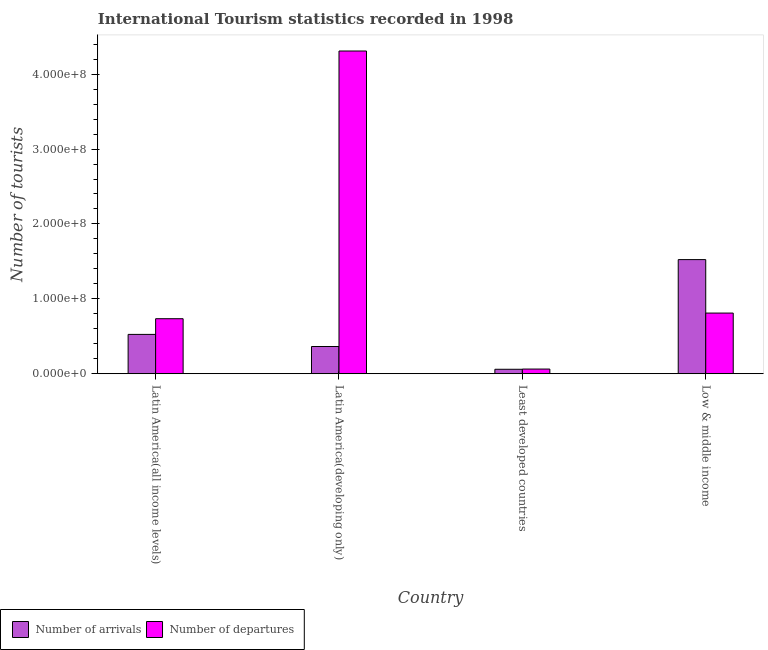What is the label of the 3rd group of bars from the left?
Offer a terse response. Least developed countries. What is the number of tourist departures in Least developed countries?
Give a very brief answer. 6.26e+06. Across all countries, what is the maximum number of tourist arrivals?
Your response must be concise. 1.52e+08. Across all countries, what is the minimum number of tourist arrivals?
Your answer should be very brief. 5.95e+06. In which country was the number of tourist arrivals maximum?
Your response must be concise. Low & middle income. In which country was the number of tourist departures minimum?
Your answer should be very brief. Least developed countries. What is the total number of tourist departures in the graph?
Keep it short and to the point. 5.92e+08. What is the difference between the number of tourist arrivals in Latin America(all income levels) and that in Low & middle income?
Offer a very short reply. -9.99e+07. What is the difference between the number of tourist departures in Latin America(developing only) and the number of tourist arrivals in Low & middle income?
Your answer should be compact. 2.79e+08. What is the average number of tourist departures per country?
Give a very brief answer. 1.48e+08. What is the difference between the number of tourist arrivals and number of tourist departures in Latin America(developing only)?
Make the answer very short. -3.95e+08. In how many countries, is the number of tourist departures greater than 260000000 ?
Give a very brief answer. 1. What is the ratio of the number of tourist departures in Least developed countries to that in Low & middle income?
Offer a very short reply. 0.08. Is the number of tourist departures in Latin America(developing only) less than that in Low & middle income?
Give a very brief answer. No. What is the difference between the highest and the second highest number of tourist arrivals?
Provide a short and direct response. 9.99e+07. What is the difference between the highest and the lowest number of tourist arrivals?
Make the answer very short. 1.46e+08. In how many countries, is the number of tourist arrivals greater than the average number of tourist arrivals taken over all countries?
Give a very brief answer. 1. Is the sum of the number of tourist arrivals in Latin America(all income levels) and Low & middle income greater than the maximum number of tourist departures across all countries?
Give a very brief answer. No. What does the 2nd bar from the left in Least developed countries represents?
Ensure brevity in your answer.  Number of departures. What does the 2nd bar from the right in Least developed countries represents?
Give a very brief answer. Number of arrivals. Are all the bars in the graph horizontal?
Offer a very short reply. No. How many countries are there in the graph?
Ensure brevity in your answer.  4. Are the values on the major ticks of Y-axis written in scientific E-notation?
Make the answer very short. Yes. Does the graph contain any zero values?
Provide a succinct answer. No. Does the graph contain grids?
Your response must be concise. No. What is the title of the graph?
Offer a very short reply. International Tourism statistics recorded in 1998. Does "Urban agglomerations" appear as one of the legend labels in the graph?
Your answer should be compact. No. What is the label or title of the Y-axis?
Your answer should be very brief. Number of tourists. What is the Number of tourists of Number of arrivals in Latin America(all income levels)?
Keep it short and to the point. 5.25e+07. What is the Number of tourists of Number of departures in Latin America(all income levels)?
Your answer should be very brief. 7.35e+07. What is the Number of tourists of Number of arrivals in Latin America(developing only)?
Keep it short and to the point. 3.64e+07. What is the Number of tourists in Number of departures in Latin America(developing only)?
Offer a very short reply. 4.31e+08. What is the Number of tourists of Number of arrivals in Least developed countries?
Your answer should be compact. 5.95e+06. What is the Number of tourists of Number of departures in Least developed countries?
Offer a very short reply. 6.26e+06. What is the Number of tourists of Number of arrivals in Low & middle income?
Make the answer very short. 1.52e+08. What is the Number of tourists in Number of departures in Low & middle income?
Give a very brief answer. 8.10e+07. Across all countries, what is the maximum Number of tourists of Number of arrivals?
Your answer should be compact. 1.52e+08. Across all countries, what is the maximum Number of tourists in Number of departures?
Make the answer very short. 4.31e+08. Across all countries, what is the minimum Number of tourists of Number of arrivals?
Your answer should be compact. 5.95e+06. Across all countries, what is the minimum Number of tourists of Number of departures?
Give a very brief answer. 6.26e+06. What is the total Number of tourists of Number of arrivals in the graph?
Offer a very short reply. 2.47e+08. What is the total Number of tourists in Number of departures in the graph?
Offer a terse response. 5.92e+08. What is the difference between the Number of tourists in Number of arrivals in Latin America(all income levels) and that in Latin America(developing only)?
Keep it short and to the point. 1.62e+07. What is the difference between the Number of tourists in Number of departures in Latin America(all income levels) and that in Latin America(developing only)?
Your answer should be compact. -3.57e+08. What is the difference between the Number of tourists of Number of arrivals in Latin America(all income levels) and that in Least developed countries?
Offer a terse response. 4.66e+07. What is the difference between the Number of tourists in Number of departures in Latin America(all income levels) and that in Least developed countries?
Keep it short and to the point. 6.72e+07. What is the difference between the Number of tourists in Number of arrivals in Latin America(all income levels) and that in Low & middle income?
Keep it short and to the point. -9.99e+07. What is the difference between the Number of tourists of Number of departures in Latin America(all income levels) and that in Low & middle income?
Provide a succinct answer. -7.53e+06. What is the difference between the Number of tourists of Number of arrivals in Latin America(developing only) and that in Least developed countries?
Your answer should be compact. 3.04e+07. What is the difference between the Number of tourists of Number of departures in Latin America(developing only) and that in Least developed countries?
Give a very brief answer. 4.25e+08. What is the difference between the Number of tourists in Number of arrivals in Latin America(developing only) and that in Low & middle income?
Provide a short and direct response. -1.16e+08. What is the difference between the Number of tourists in Number of departures in Latin America(developing only) and that in Low & middle income?
Your response must be concise. 3.50e+08. What is the difference between the Number of tourists in Number of arrivals in Least developed countries and that in Low & middle income?
Provide a short and direct response. -1.46e+08. What is the difference between the Number of tourists of Number of departures in Least developed countries and that in Low & middle income?
Provide a succinct answer. -7.47e+07. What is the difference between the Number of tourists of Number of arrivals in Latin America(all income levels) and the Number of tourists of Number of departures in Latin America(developing only)?
Provide a short and direct response. -3.78e+08. What is the difference between the Number of tourists in Number of arrivals in Latin America(all income levels) and the Number of tourists in Number of departures in Least developed countries?
Your response must be concise. 4.63e+07. What is the difference between the Number of tourists in Number of arrivals in Latin America(all income levels) and the Number of tourists in Number of departures in Low & middle income?
Your response must be concise. -2.85e+07. What is the difference between the Number of tourists of Number of arrivals in Latin America(developing only) and the Number of tourists of Number of departures in Least developed countries?
Give a very brief answer. 3.01e+07. What is the difference between the Number of tourists of Number of arrivals in Latin America(developing only) and the Number of tourists of Number of departures in Low & middle income?
Offer a very short reply. -4.46e+07. What is the difference between the Number of tourists of Number of arrivals in Least developed countries and the Number of tourists of Number of departures in Low & middle income?
Offer a very short reply. -7.51e+07. What is the average Number of tourists of Number of arrivals per country?
Your answer should be compact. 6.18e+07. What is the average Number of tourists of Number of departures per country?
Give a very brief answer. 1.48e+08. What is the difference between the Number of tourists of Number of arrivals and Number of tourists of Number of departures in Latin America(all income levels)?
Keep it short and to the point. -2.09e+07. What is the difference between the Number of tourists of Number of arrivals and Number of tourists of Number of departures in Latin America(developing only)?
Offer a very short reply. -3.95e+08. What is the difference between the Number of tourists in Number of arrivals and Number of tourists in Number of departures in Least developed countries?
Your answer should be compact. -3.08e+05. What is the difference between the Number of tourists of Number of arrivals and Number of tourists of Number of departures in Low & middle income?
Your answer should be compact. 7.14e+07. What is the ratio of the Number of tourists in Number of arrivals in Latin America(all income levels) to that in Latin America(developing only)?
Provide a short and direct response. 1.44. What is the ratio of the Number of tourists of Number of departures in Latin America(all income levels) to that in Latin America(developing only)?
Your answer should be very brief. 0.17. What is the ratio of the Number of tourists of Number of arrivals in Latin America(all income levels) to that in Least developed countries?
Offer a very short reply. 8.83. What is the ratio of the Number of tourists in Number of departures in Latin America(all income levels) to that in Least developed countries?
Offer a terse response. 11.74. What is the ratio of the Number of tourists of Number of arrivals in Latin America(all income levels) to that in Low & middle income?
Your response must be concise. 0.34. What is the ratio of the Number of tourists of Number of departures in Latin America(all income levels) to that in Low & middle income?
Your answer should be very brief. 0.91. What is the ratio of the Number of tourists of Number of arrivals in Latin America(developing only) to that in Least developed countries?
Make the answer very short. 6.11. What is the ratio of the Number of tourists of Number of departures in Latin America(developing only) to that in Least developed countries?
Offer a terse response. 68.82. What is the ratio of the Number of tourists of Number of arrivals in Latin America(developing only) to that in Low & middle income?
Your response must be concise. 0.24. What is the ratio of the Number of tourists in Number of departures in Latin America(developing only) to that in Low & middle income?
Make the answer very short. 5.32. What is the ratio of the Number of tourists in Number of arrivals in Least developed countries to that in Low & middle income?
Make the answer very short. 0.04. What is the ratio of the Number of tourists of Number of departures in Least developed countries to that in Low & middle income?
Give a very brief answer. 0.08. What is the difference between the highest and the second highest Number of tourists of Number of arrivals?
Give a very brief answer. 9.99e+07. What is the difference between the highest and the second highest Number of tourists of Number of departures?
Make the answer very short. 3.50e+08. What is the difference between the highest and the lowest Number of tourists of Number of arrivals?
Offer a very short reply. 1.46e+08. What is the difference between the highest and the lowest Number of tourists in Number of departures?
Your answer should be compact. 4.25e+08. 